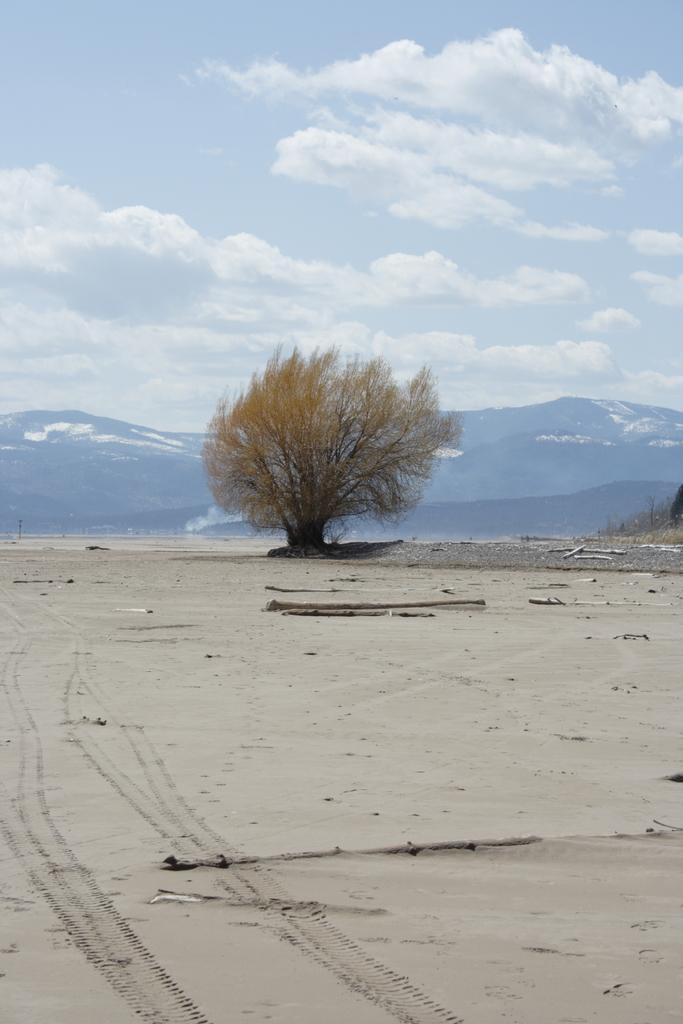Please provide a concise description of this image. This is an outside view. At the bottom, I can see the ground. In the middle of the image there is a tree. In the background there are few mountains. At the top of the image I can see the sky and clouds. 